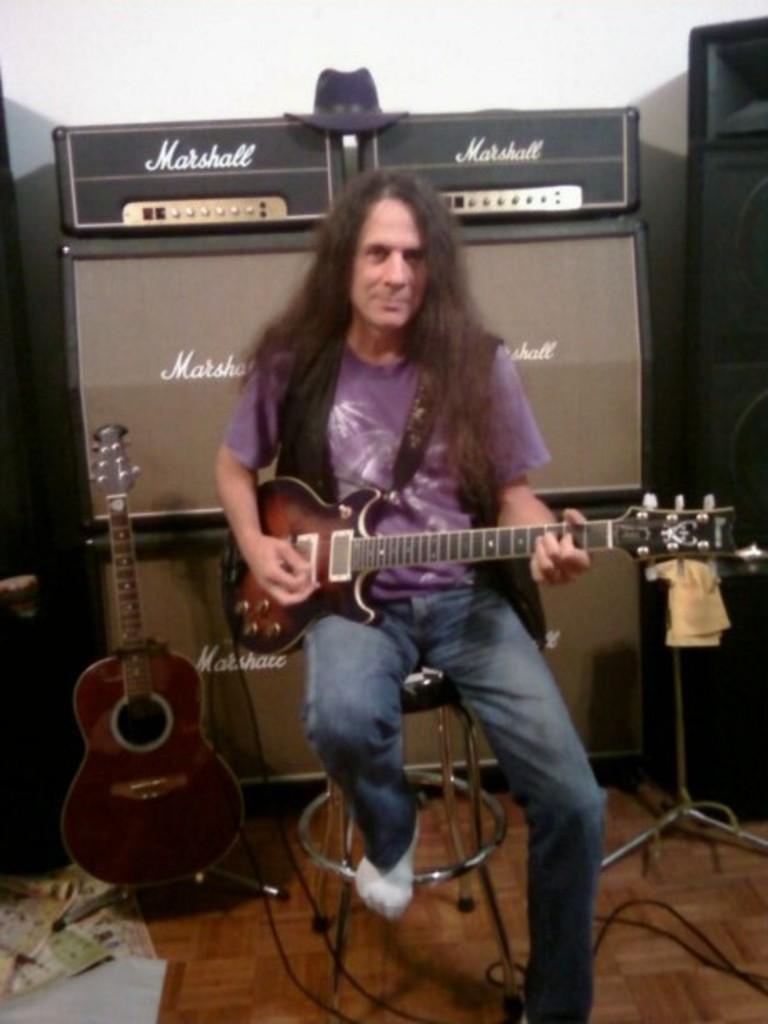Can you describe this image briefly? This is the picture of a person in blue shirt and blue jeans sitting on the chair and playing the musical instrument and behind him there are speakers, a guitar and a stand. 